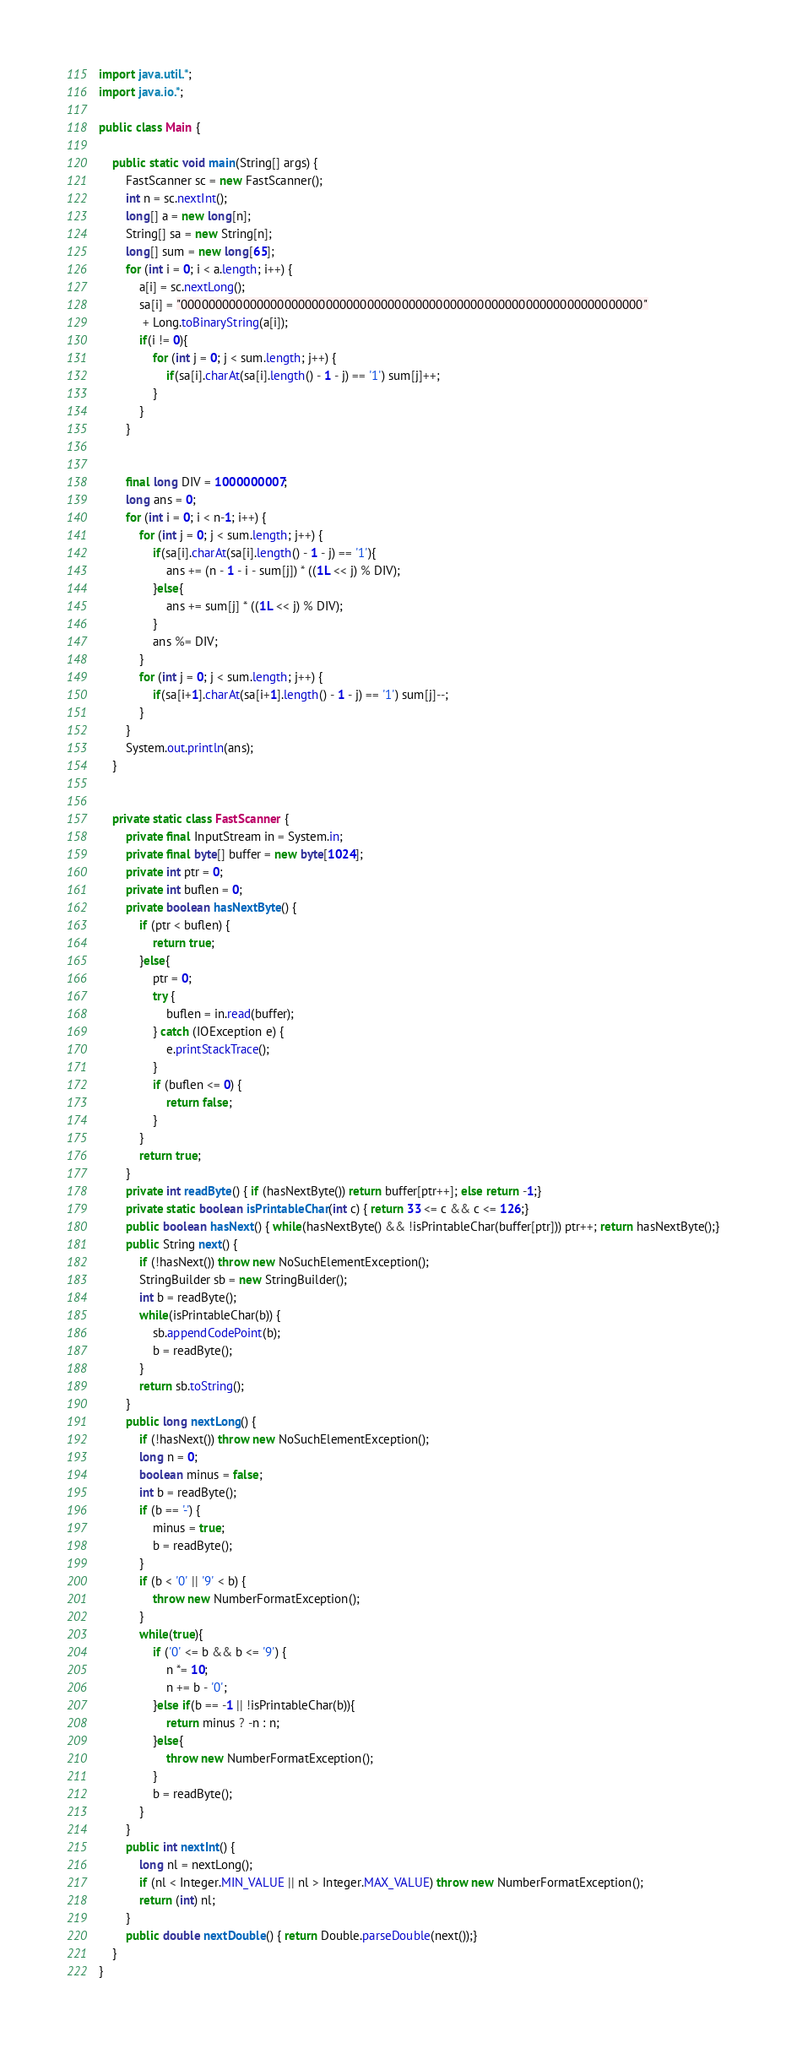Convert code to text. <code><loc_0><loc_0><loc_500><loc_500><_Java_>import java.util.*;
import java.io.*;

public class Main {

    public static void main(String[] args) {
        FastScanner sc = new FastScanner();
        int n = sc.nextInt();
        long[] a = new long[n];
        String[] sa = new String[n];
        long[] sum = new long[65];
        for (int i = 0; i < a.length; i++) {
            a[i] = sc.nextLong();
            sa[i] = "0000000000000000000000000000000000000000000000000000000000000000000"
             + Long.toBinaryString(a[i]);
            if(i != 0){
                for (int j = 0; j < sum.length; j++) {
                    if(sa[i].charAt(sa[i].length() - 1 - j) == '1') sum[j]++;
                }
            }
        }


        final long DIV = 1000000007;
        long ans = 0;
        for (int i = 0; i < n-1; i++) {
            for (int j = 0; j < sum.length; j++) {
                if(sa[i].charAt(sa[i].length() - 1 - j) == '1'){
                    ans += (n - 1 - i - sum[j]) * ((1L << j) % DIV);
                }else{
                    ans += sum[j] * ((1L << j) % DIV);
                }
                ans %= DIV;
            }
            for (int j = 0; j < sum.length; j++) {
                if(sa[i+1].charAt(sa[i+1].length() - 1 - j) == '1') sum[j]--;
            }
        }
        System.out.println(ans);
    }


    private static class FastScanner {
        private final InputStream in = System.in;
        private final byte[] buffer = new byte[1024];
        private int ptr = 0;
        private int buflen = 0;
        private boolean hasNextByte() {
            if (ptr < buflen) {
                return true;
            }else{
                ptr = 0;
                try {
                    buflen = in.read(buffer);
                } catch (IOException e) {
                    e.printStackTrace();
                }
                if (buflen <= 0) {
                    return false;
                }
            }
            return true;
        }
        private int readByte() { if (hasNextByte()) return buffer[ptr++]; else return -1;}
        private static boolean isPrintableChar(int c) { return 33 <= c && c <= 126;}
        public boolean hasNext() { while(hasNextByte() && !isPrintableChar(buffer[ptr])) ptr++; return hasNextByte();}
        public String next() {
            if (!hasNext()) throw new NoSuchElementException();
            StringBuilder sb = new StringBuilder();
            int b = readByte();
            while(isPrintableChar(b)) {
                sb.appendCodePoint(b);
                b = readByte();
            }
            return sb.toString();
        }
        public long nextLong() {
            if (!hasNext()) throw new NoSuchElementException();
            long n = 0;
            boolean minus = false;
            int b = readByte();
            if (b == '-') {
                minus = true;
                b = readByte();
            }
            if (b < '0' || '9' < b) {
                throw new NumberFormatException();
            }
            while(true){
                if ('0' <= b && b <= '9') {
                    n *= 10;
                    n += b - '0';
                }else if(b == -1 || !isPrintableChar(b)){
                    return minus ? -n : n;
                }else{
                    throw new NumberFormatException();
                }
                b = readByte();
            }
        }
        public int nextInt() {
            long nl = nextLong();
            if (nl < Integer.MIN_VALUE || nl > Integer.MAX_VALUE) throw new NumberFormatException();
            return (int) nl;
        }
        public double nextDouble() { return Double.parseDouble(next());}
    }
}
</code> 